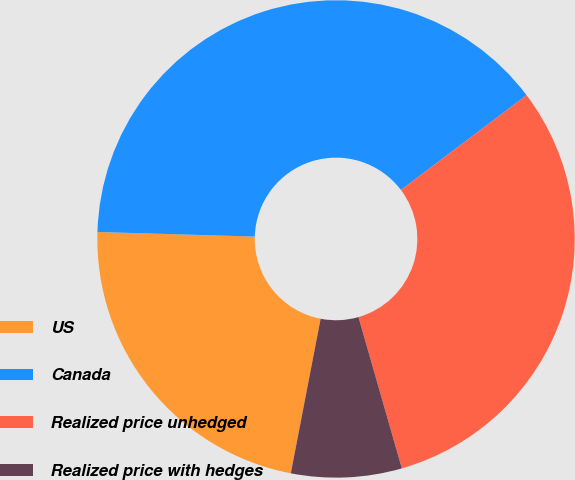Convert chart. <chart><loc_0><loc_0><loc_500><loc_500><pie_chart><fcel>US<fcel>Canada<fcel>Realized price unhedged<fcel>Realized price with hedges<nl><fcel>22.43%<fcel>39.25%<fcel>30.84%<fcel>7.48%<nl></chart> 